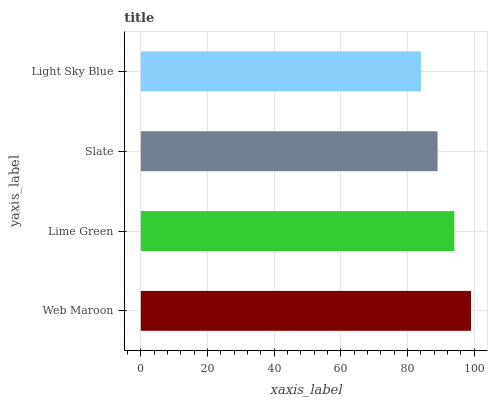Is Light Sky Blue the minimum?
Answer yes or no. Yes. Is Web Maroon the maximum?
Answer yes or no. Yes. Is Lime Green the minimum?
Answer yes or no. No. Is Lime Green the maximum?
Answer yes or no. No. Is Web Maroon greater than Lime Green?
Answer yes or no. Yes. Is Lime Green less than Web Maroon?
Answer yes or no. Yes. Is Lime Green greater than Web Maroon?
Answer yes or no. No. Is Web Maroon less than Lime Green?
Answer yes or no. No. Is Lime Green the high median?
Answer yes or no. Yes. Is Slate the low median?
Answer yes or no. Yes. Is Slate the high median?
Answer yes or no. No. Is Lime Green the low median?
Answer yes or no. No. 